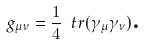Convert formula to latex. <formula><loc_0><loc_0><loc_500><loc_500>g _ { \mu \nu } = \frac { 1 } { 4 } \ t r ( \gamma _ { \mu } \gamma _ { \nu } ) \text {.}</formula> 